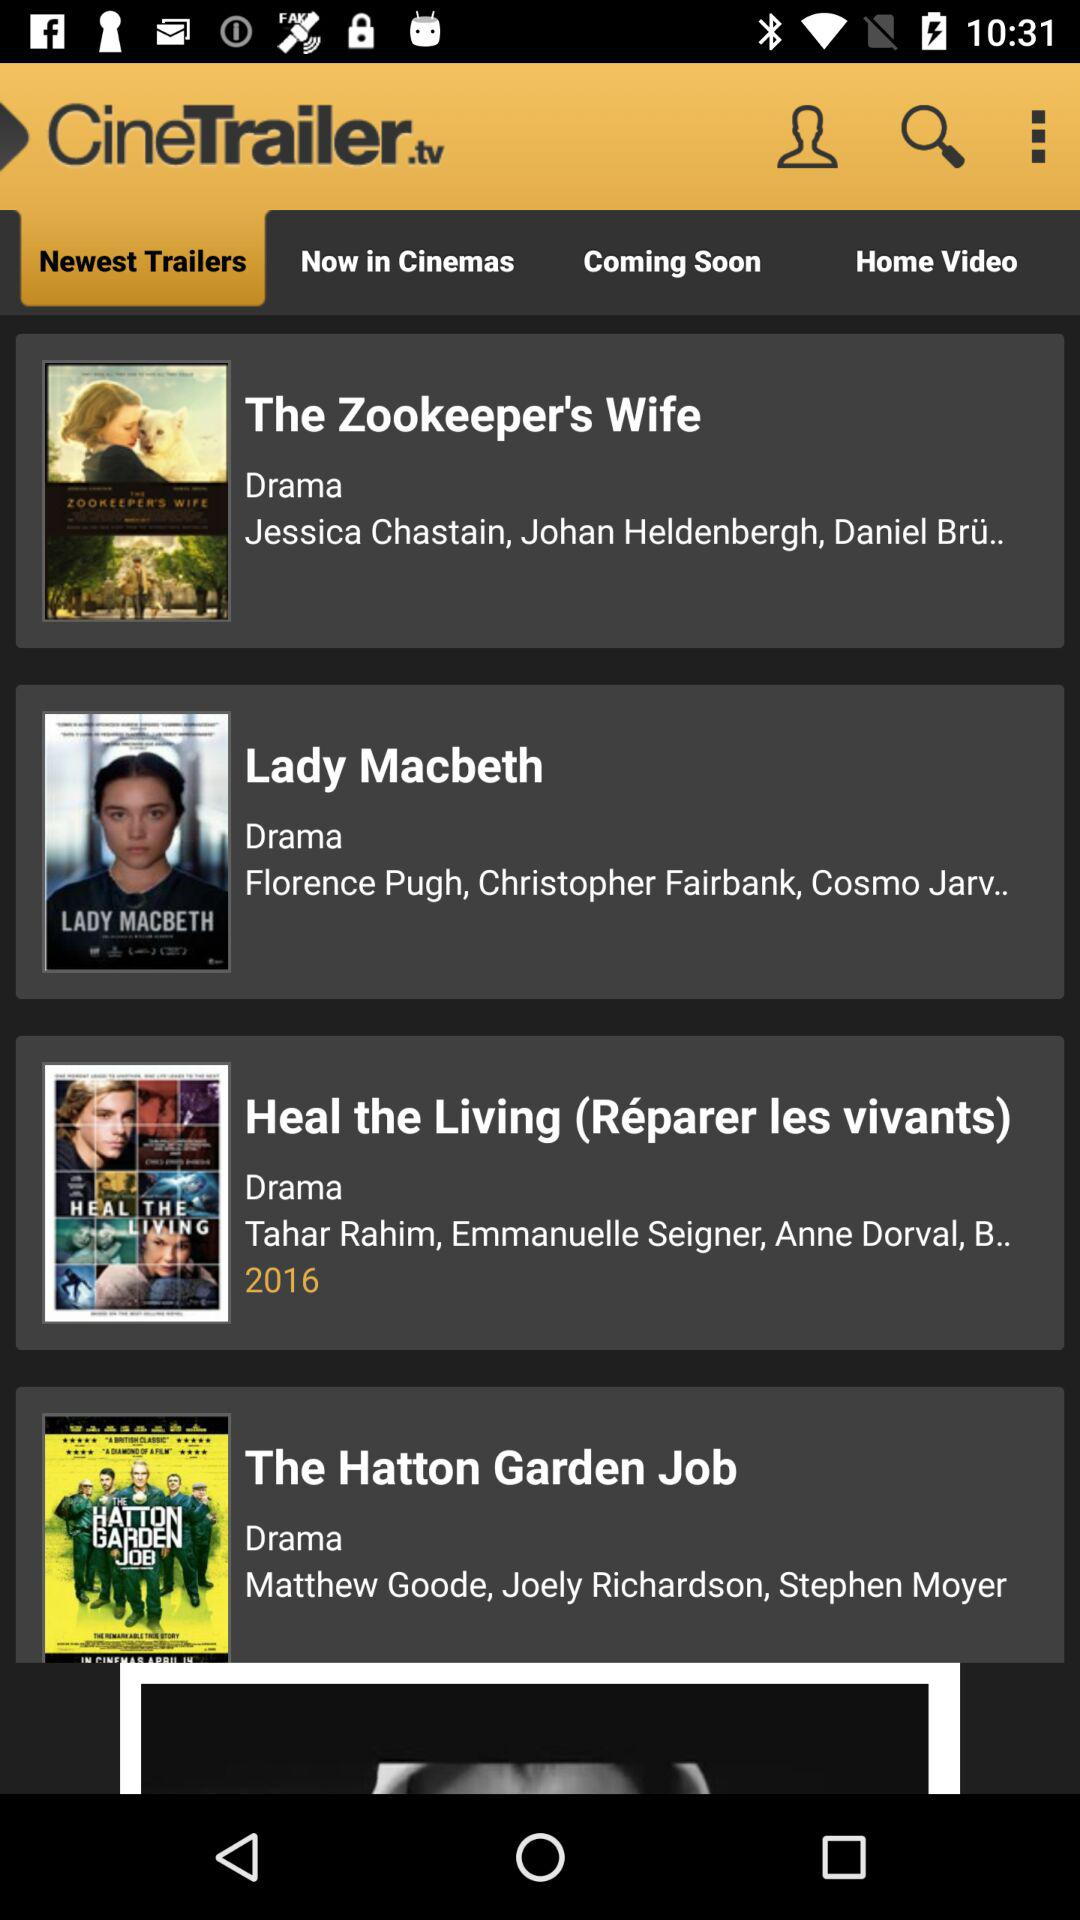What are the newest trailers? The newest trailers are "The Zookeeper's Wife", "Lady Macbeth", "Heal the Living (Reparer les vivants)", and "The Hatton Garden Job". 